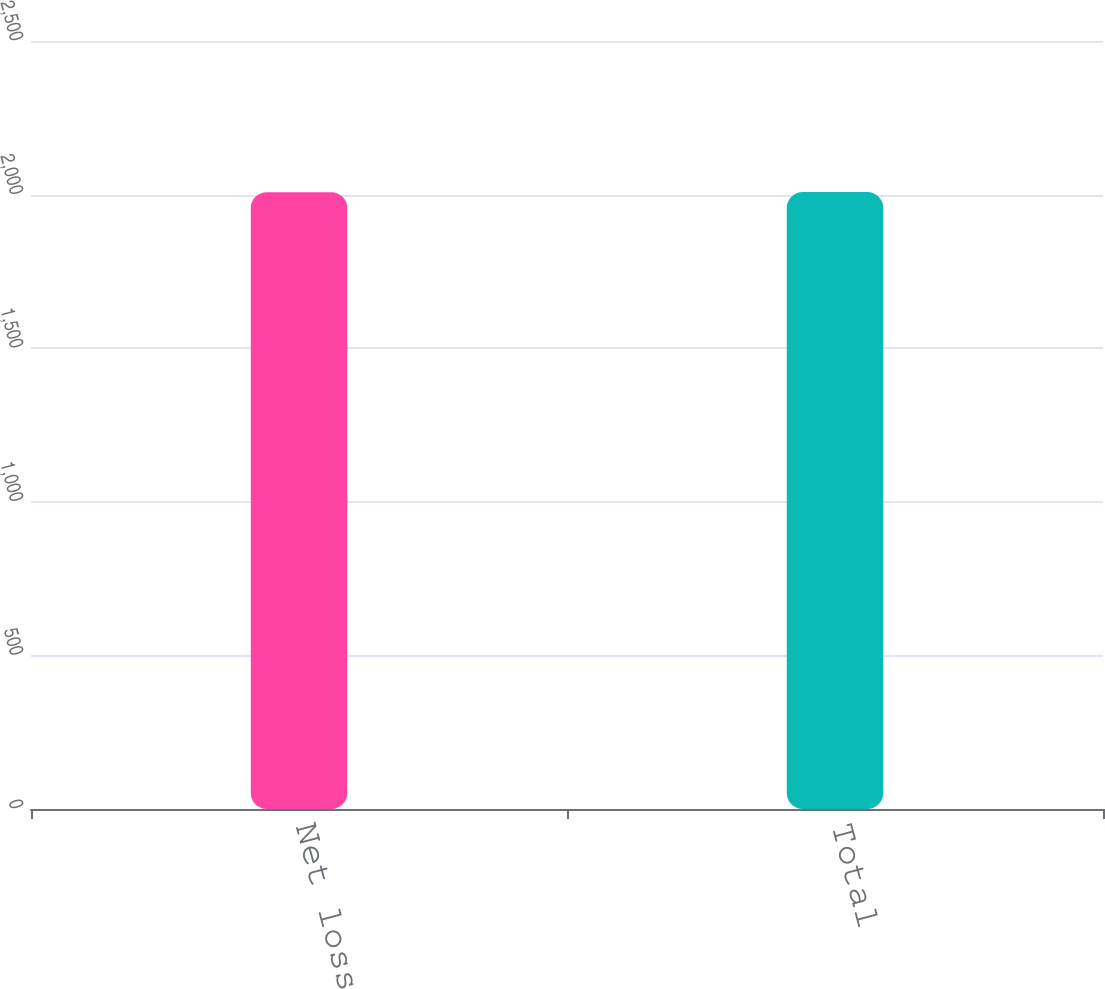Convert chart. <chart><loc_0><loc_0><loc_500><loc_500><bar_chart><fcel>Net loss<fcel>Total<nl><fcel>2008<fcel>2008.1<nl></chart> 